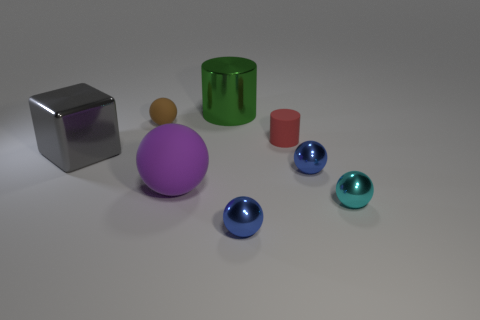What number of objects are rubber objects or small purple matte balls?
Provide a short and direct response. 3. What is the size of the rubber object that is right of the small matte sphere and behind the gray metal cube?
Ensure brevity in your answer.  Small. How many tiny red cylinders are there?
Your answer should be very brief. 1. What number of cubes are cyan things or tiny red things?
Make the answer very short. 0. How many small blue metallic spheres are left of the small blue shiny object behind the matte object in front of the big block?
Provide a short and direct response. 1. There is a cylinder that is the same size as the purple ball; what is its color?
Make the answer very short. Green. How many other things are the same color as the metallic cube?
Your response must be concise. 0. Are there more small brown spheres to the right of the small cyan object than cylinders?
Your answer should be very brief. No. Is the material of the green cylinder the same as the brown object?
Keep it short and to the point. No. How many objects are either blue metal spheres that are in front of the purple sphere or tiny cyan metal objects?
Provide a succinct answer. 2. 